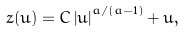Convert formula to latex. <formula><loc_0><loc_0><loc_500><loc_500>z ( u ) = C \left | u \right | ^ { a / ( a - 1 ) } + u ,</formula> 